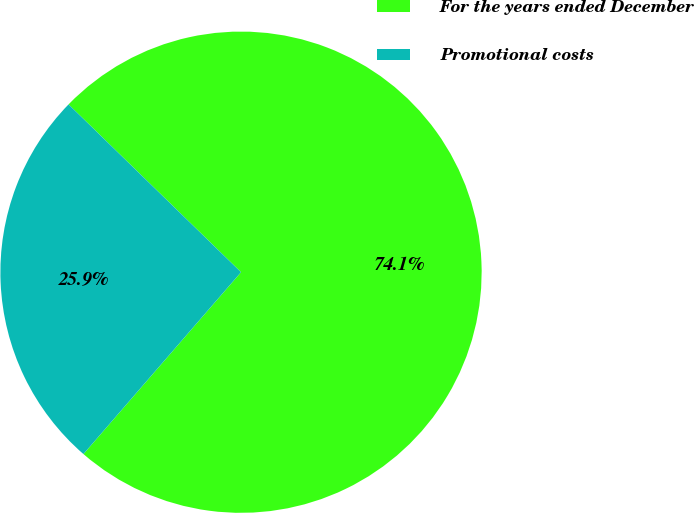Convert chart. <chart><loc_0><loc_0><loc_500><loc_500><pie_chart><fcel>For the years ended December<fcel>Promotional costs<nl><fcel>74.08%<fcel>25.92%<nl></chart> 